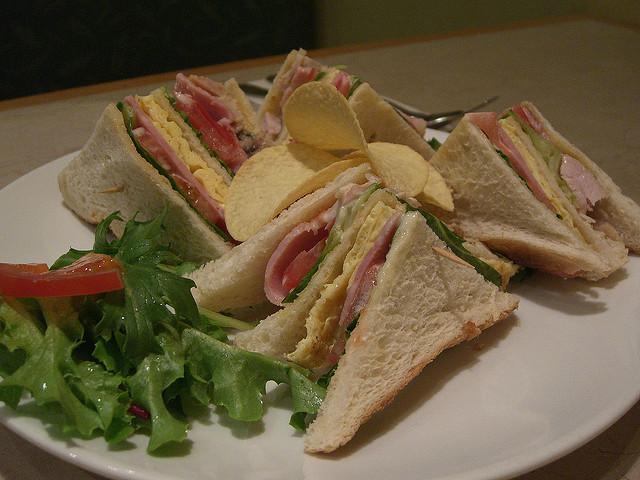How many sandwiches are visible?
Give a very brief answer. 5. 